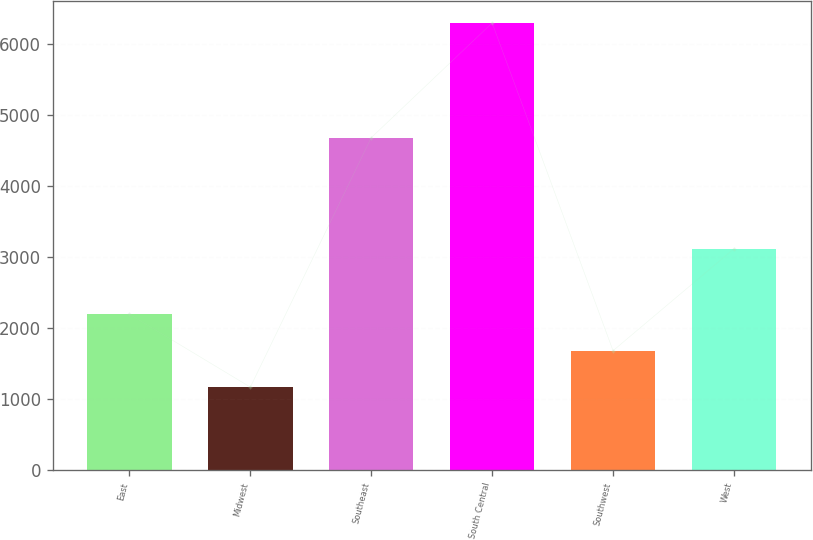<chart> <loc_0><loc_0><loc_500><loc_500><bar_chart><fcel>East<fcel>Midwest<fcel>Southeast<fcel>South Central<fcel>Southwest<fcel>West<nl><fcel>2191.2<fcel>1164<fcel>4682<fcel>6300<fcel>1677.6<fcel>3115<nl></chart> 